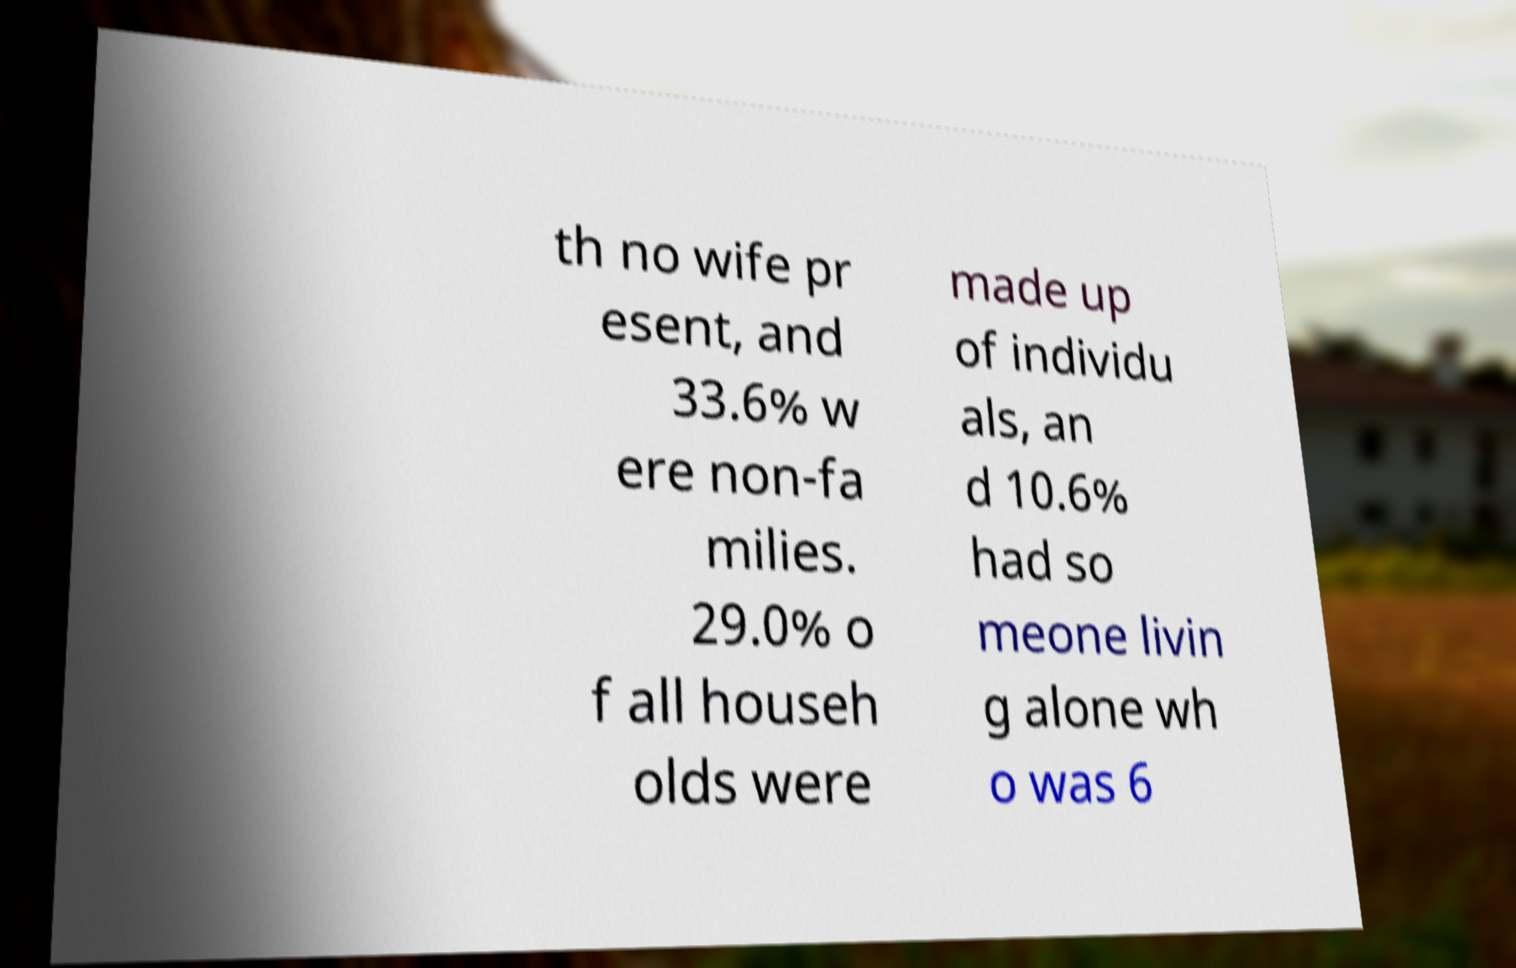Could you extract and type out the text from this image? th no wife pr esent, and 33.6% w ere non-fa milies. 29.0% o f all househ olds were made up of individu als, an d 10.6% had so meone livin g alone wh o was 6 